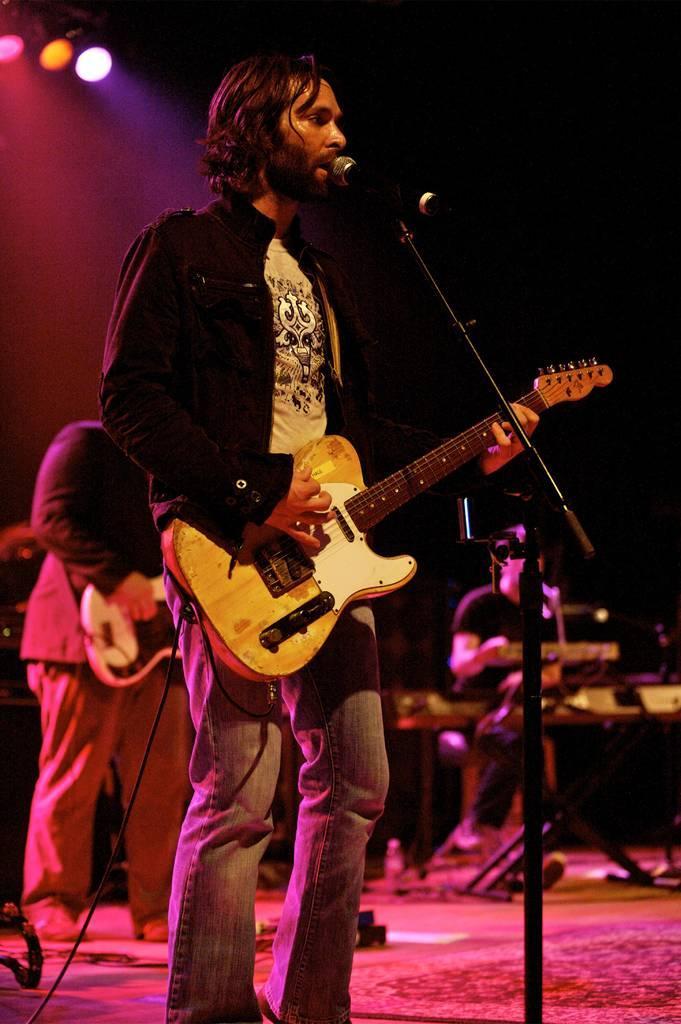In one or two sentences, can you explain what this image depicts? The persons wearing black dress is playing guitar in front of a mic and there is a person playing piano in the background. 